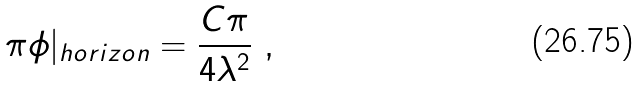Convert formula to latex. <formula><loc_0><loc_0><loc_500><loc_500>\pi \phi | _ { h o r i z o n } = \frac { C \pi } { 4 \lambda ^ { 2 } } \ ,</formula> 